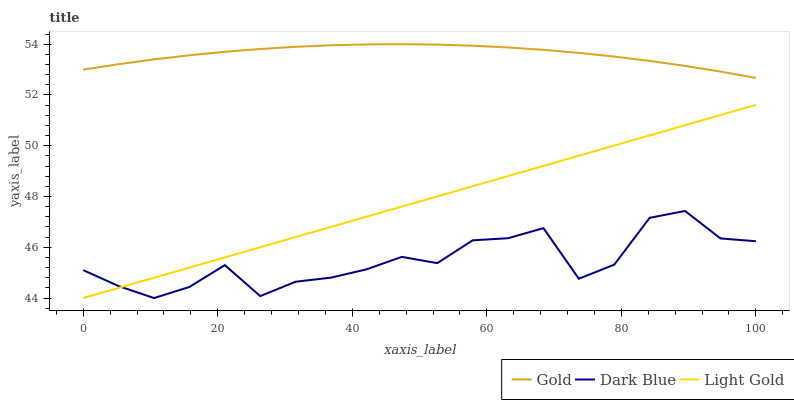Does Dark Blue have the minimum area under the curve?
Answer yes or no. Yes. Does Gold have the maximum area under the curve?
Answer yes or no. Yes. Does Light Gold have the minimum area under the curve?
Answer yes or no. No. Does Light Gold have the maximum area under the curve?
Answer yes or no. No. Is Light Gold the smoothest?
Answer yes or no. Yes. Is Dark Blue the roughest?
Answer yes or no. Yes. Is Gold the smoothest?
Answer yes or no. No. Is Gold the roughest?
Answer yes or no. No. Does Gold have the lowest value?
Answer yes or no. No. Does Light Gold have the highest value?
Answer yes or no. No. Is Dark Blue less than Gold?
Answer yes or no. Yes. Is Gold greater than Light Gold?
Answer yes or no. Yes. Does Dark Blue intersect Gold?
Answer yes or no. No. 